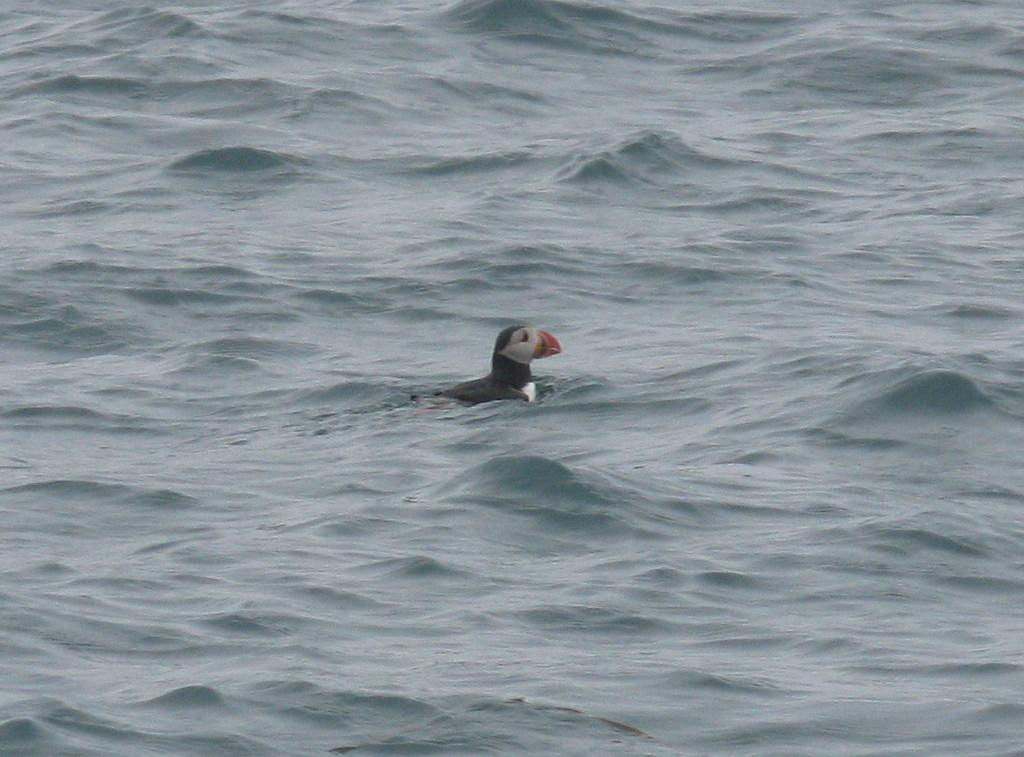What type of animal is in the image? There is a bird in the image. Where is the bird located in the image? The bird is in the water. What type of waste is being transported by the chickens in the image? There are no chickens or waste present in the image; it features a bird in the water. 